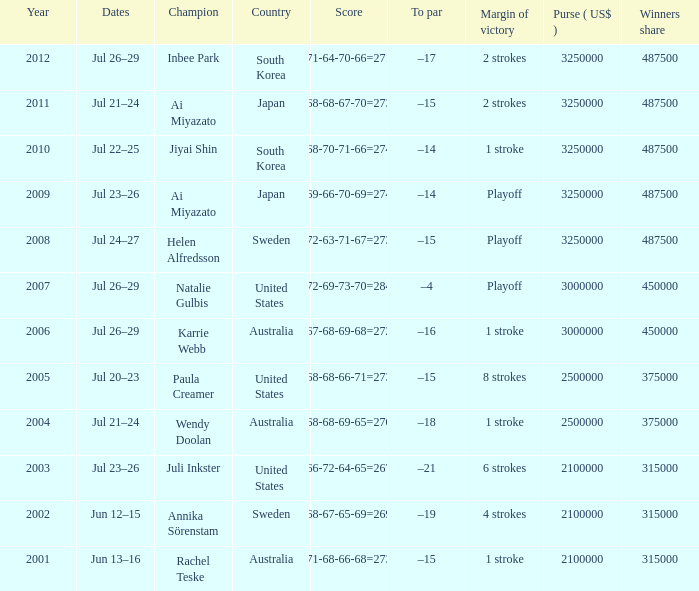For how many years did jiyai shin hold the champion title? 1.0. 